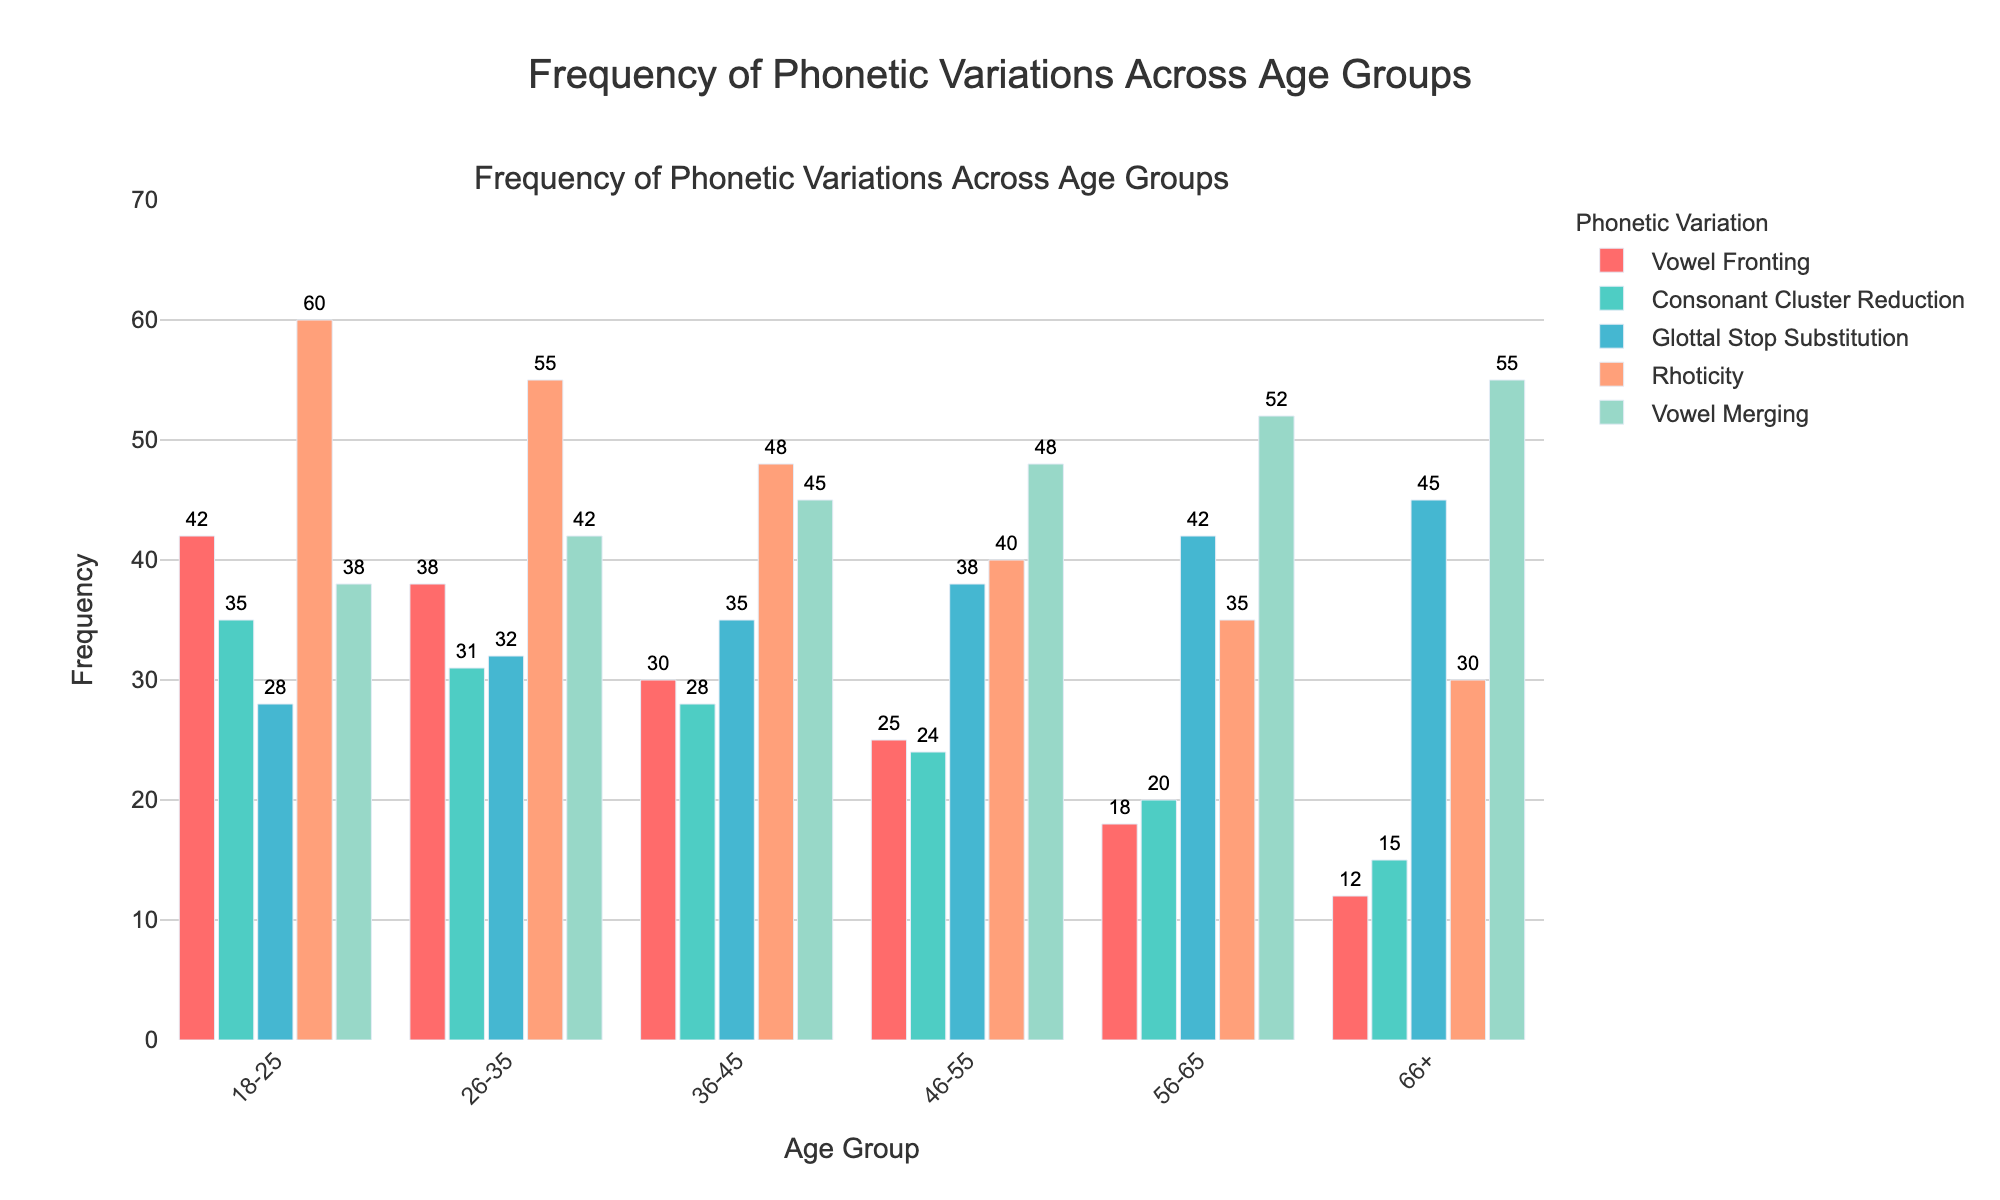Which age group has the highest frequency of Glottal Stop Substitution? To find this, we look at the Glottal Stop Substitution bars and identify which one is the tallest. From the chart, the age group 66+ has the tallest bar for Glottal Stop Substitution.
Answer: 66+ For age group 26-35, which phonetic variation has the highest frequency? We inspect the bars above the 26-35 age group. The tallest bar above this group represents Rhoticity with a value of 55.
Answer: Rhoticity What is the total frequency of Vowel Fronting for the age groups 18-25 and 46-55 combined? To get the total, we add the frequencies of Vowel Fronting for these age groups: 42 (18-25) + 25 (46-55).
Answer: 67 Which phonetic variation shows a decreasing trend in frequency as age increases? We observe each phonetic variation's bars across different age groups. For Vowel Fronting, the bars continuously decrease from left to right, indicating a decreasing trend.
Answer: Vowel Fronting By how much does the frequency of Rhoticity decrease from the 18-25 age group to the 66+ age group? We subtract the frequency of Rhoticity for 66+ from that of 18-25: 60 - 30.
Answer: 30 Which age group has the lowest frequency of Consonant Cluster Reduction? We examine the heights of the Consonant Cluster Reduction bars across age groups. The shortest bar corresponds to the age group 66+.
Answer: 66+ What is the average frequency of Vowel Merging across all age groups? To find the average, we sum the frequencies for Vowel Merging across all age groups and divide by the number of age groups: (38 + 42 + 45 + 48 + 52 + 55) / 6.
Answer: 46 In the age group 36-45, which phonetic variations have the same frequency? We look at the heights of the bars for the 36-45 age group. Both Consonant Cluster Reduction and Glottal Stop Substitution have the same frequency of 35.
Answer: Consonant Cluster Reduction and Glottal Stop Substitution Which age group shows the highest variation in the frequencies of different phonetic variations? We find the age group with the highest difference between the maximum and minimum frequencies. For 18-25, the range is 60-28=32, 26-35 is 55-31=24, 36-45 is 48-28=20, 46-55 is 48-24=24, 56-65 is 52-18=34, and 66+ is 55-12=43. Age group 66+ has the highest variation.
Answer: 66+ 